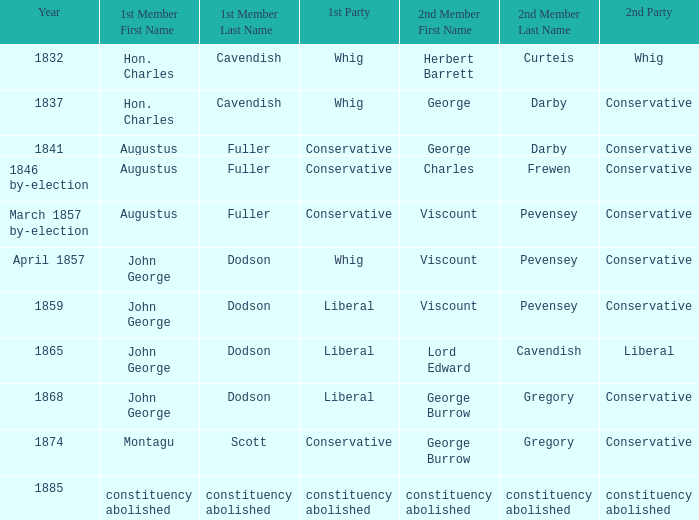In 1865, what was the first party? Liberal. 